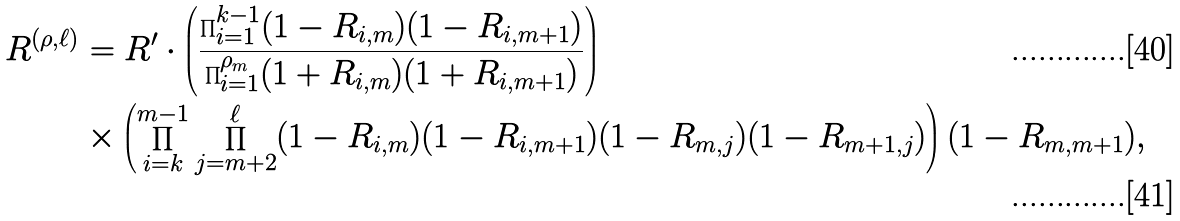<formula> <loc_0><loc_0><loc_500><loc_500>R ^ { ( \rho , \ell ) } & = R ^ { \prime } \cdot \left ( \frac { \prod _ { i = 1 } ^ { k - 1 } ( 1 - R _ { i , m } ) ( 1 - R _ { i , m + 1 } ) } { \prod _ { i = 1 } ^ { \rho _ { m } } ( 1 + R _ { i , m } ) ( 1 + R _ { i , m + 1 } ) } \right ) \\ & \times \left ( \prod _ { i = k } ^ { m - 1 } \prod _ { j = m + 2 } ^ { \ell } ( 1 - R _ { i , m } ) ( 1 - R _ { i , m + 1 } ) ( 1 - R _ { m , j } ) ( 1 - R _ { m + 1 , j } ) \right ) ( 1 - R _ { m , m + 1 } ) ,</formula> 